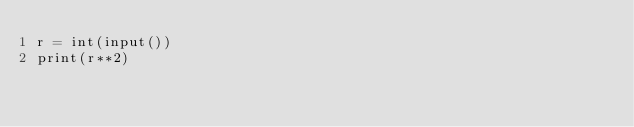<code> <loc_0><loc_0><loc_500><loc_500><_Python_>r = int(input())
print(r**2)</code> 